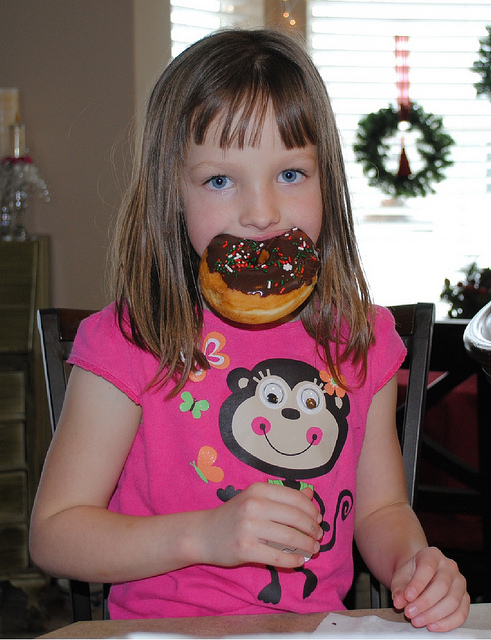<image>What is the brand of sweatshirt the little girl is wearing? I don't know the brand of the sweatshirt the little girl is wearing. It could be 'oshkosh', 'carters', 'animal', 'disney', 'monkey' or 'justice'. What is the brand of sweatshirt the little girl is wearing? I don't know what brand of sweatshirt the little girl is wearing. 